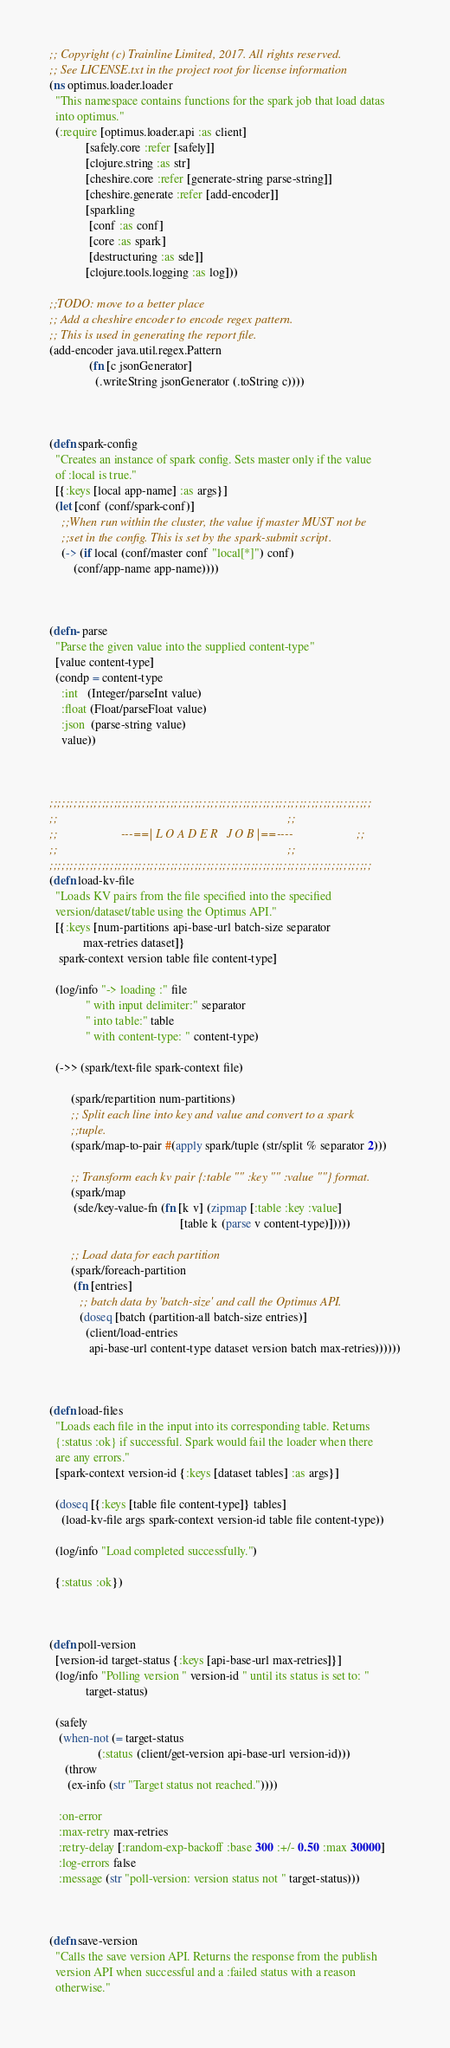<code> <loc_0><loc_0><loc_500><loc_500><_Clojure_>;; Copyright (c) Trainline Limited, 2017. All rights reserved.
;; See LICENSE.txt in the project root for license information
(ns optimus.loader.loader
  "This namespace contains functions for the spark job that load datas
  into optimus."
  (:require [optimus.loader.api :as client]
            [safely.core :refer [safely]]
            [clojure.string :as str]
            [cheshire.core :refer [generate-string parse-string]]
            [cheshire.generate :refer [add-encoder]]
            [sparkling
             [conf :as conf]
             [core :as spark]
             [destructuring :as sde]]
            [clojure.tools.logging :as log]))

;;TODO: move to a better place
;; Add a cheshire encoder to encode regex pattern.
;; This is used in generating the report file.
(add-encoder java.util.regex.Pattern
             (fn [c jsonGenerator]
               (.writeString jsonGenerator (.toString c))))



(defn spark-config
  "Creates an instance of spark config. Sets master only if the value
  of :local is true."
  [{:keys [local app-name] :as args}]
  (let [conf (conf/spark-conf)]
    ;;When run within the cluster, the value if master MUST not be
    ;;set in the config. This is set by the spark-submit script.
    (-> (if local (conf/master conf "local[*]") conf)
        (conf/app-name app-name))))



(defn- parse
  "Parse the given value into the supplied content-type"
  [value content-type]
  (condp = content-type
    :int   (Integer/parseInt value)
    :float (Float/parseFloat value)
    :json  (parse-string value)
    value))



;;;;;;;;;;;;;;;;;;;;;;;;;;;;;;;;;;;;;;;;;;;;;;;;;;;;;;;;;;;;;;;;;;;;;;;;;;;;;;;;
;;                                                                            ;;
;;                     ---==| L O A D E R   J O B |==----                     ;;
;;                                                                            ;;
;;;;;;;;;;;;;;;;;;;;;;;;;;;;;;;;;;;;;;;;;;;;;;;;;;;;;;;;;;;;;;;;;;;;;;;;;;;;;;;;
(defn load-kv-file
  "Loads KV pairs from the file specified into the specified
  version/dataset/table using the Optimus API."
  [{:keys [num-partitions api-base-url batch-size separator
           max-retries dataset]}
   spark-context version table file content-type]

  (log/info "-> loading :" file
            " with input delimiter:" separator
            " into table:" table
            " with content-type: " content-type)

  (->> (spark/text-file spark-context file)

       (spark/repartition num-partitions)
       ;; Split each line into key and value and convert to a spark
       ;;tuple.
       (spark/map-to-pair #(apply spark/tuple (str/split % separator 2)))

       ;; Transform each kv pair {:table "" :key "" :value ""} format.
       (spark/map
        (sde/key-value-fn (fn [k v] (zipmap [:table :key :value]
                                           [table k (parse v content-type)]))))

       ;; Load data for each partition
       (spark/foreach-partition
        (fn [entries]
          ;; batch data by 'batch-size' and call the Optimus API.
          (doseq [batch (partition-all batch-size entries)]
            (client/load-entries
             api-base-url content-type dataset version batch max-retries))))))



(defn load-files
  "Loads each file in the input into its corresponding table. Returns
  {:status :ok} if successful. Spark would fail the loader when there
  are any errors."
  [spark-context version-id {:keys [dataset tables] :as args}]

  (doseq [{:keys [table file content-type]} tables]
    (load-kv-file args spark-context version-id table file content-type))

  (log/info "Load completed successfully.")

  {:status :ok})



(defn poll-version
  [version-id target-status {:keys [api-base-url max-retries]}]
  (log/info "Polling version " version-id " until its status is set to: "
            target-status)

  (safely
   (when-not (= target-status
                (:status (client/get-version api-base-url version-id)))
     (throw
      (ex-info (str "Target status not reached."))))

   :on-error
   :max-retry max-retries
   :retry-delay [:random-exp-backoff :base 300 :+/- 0.50 :max 30000]
   :log-errors false
   :message (str "poll-version: version status not " target-status)))



(defn save-version
  "Calls the save version API. Returns the response from the publish
  version API when successful and a :failed status with a reason
  otherwise."</code> 